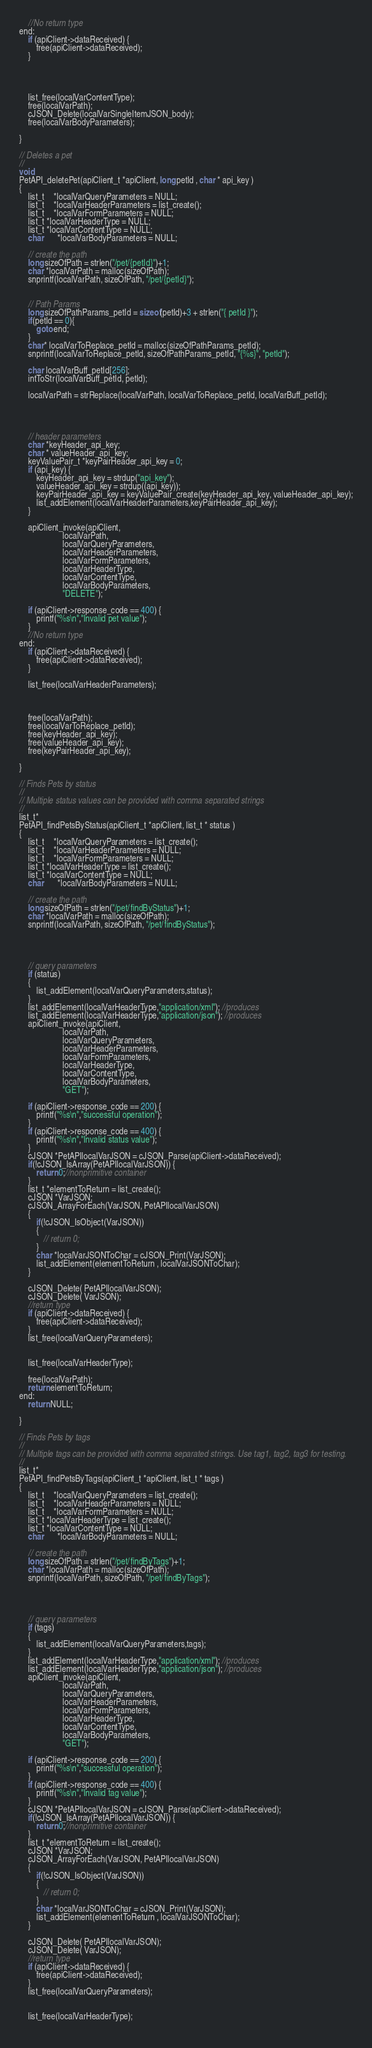Convert code to text. <code><loc_0><loc_0><loc_500><loc_500><_C_>    //No return type
end:
    if (apiClient->dataReceived) {
        free(apiClient->dataReceived);
    }
    
    
    
    
    list_free(localVarContentType);
    free(localVarPath);
    cJSON_Delete(localVarSingleItemJSON_body);
    free(localVarBodyParameters);

}

// Deletes a pet
//
void
PetAPI_deletePet(apiClient_t *apiClient, long petId , char * api_key )
{
    list_t    *localVarQueryParameters = NULL;
    list_t    *localVarHeaderParameters = list_create();
    list_t    *localVarFormParameters = NULL;
    list_t *localVarHeaderType = NULL;
    list_t *localVarContentType = NULL;
    char      *localVarBodyParameters = NULL;

    // create the path
    long sizeOfPath = strlen("/pet/{petId}")+1;
    char *localVarPath = malloc(sizeOfPath);
    snprintf(localVarPath, sizeOfPath, "/pet/{petId}");


    // Path Params
    long sizeOfPathParams_petId = sizeof(petId)+3 + strlen("{ petId }");
    if(petId == 0){
        goto end;
    }
    char* localVarToReplace_petId = malloc(sizeOfPathParams_petId);
    snprintf(localVarToReplace_petId, sizeOfPathParams_petId, "{%s}", "petId");

    char localVarBuff_petId[256];
    intToStr(localVarBuff_petId, petId);

    localVarPath = strReplace(localVarPath, localVarToReplace_petId, localVarBuff_petId);




    // header parameters
    char *keyHeader_api_key;
    char * valueHeader_api_key;
    keyValuePair_t *keyPairHeader_api_key = 0;
    if (api_key) {
        keyHeader_api_key = strdup("api_key");
        valueHeader_api_key = strdup((api_key));
        keyPairHeader_api_key = keyValuePair_create(keyHeader_api_key, valueHeader_api_key);
        list_addElement(localVarHeaderParameters,keyPairHeader_api_key);
    }

    apiClient_invoke(apiClient,
                    localVarPath,
                    localVarQueryParameters,
                    localVarHeaderParameters,
                    localVarFormParameters,
                    localVarHeaderType,
                    localVarContentType,
                    localVarBodyParameters,
                    "DELETE");

    if (apiClient->response_code == 400) {
        printf("%s\n","Invalid pet value");
    }
    //No return type
end:
    if (apiClient->dataReceived) {
        free(apiClient->dataReceived);
    }
    
    list_free(localVarHeaderParameters);
    
    
    
    free(localVarPath);
    free(localVarToReplace_petId);
    free(keyHeader_api_key);
    free(valueHeader_api_key);
    free(keyPairHeader_api_key);

}

// Finds Pets by status
//
// Multiple status values can be provided with comma separated strings
//
list_t*
PetAPI_findPetsByStatus(apiClient_t *apiClient, list_t * status )
{
    list_t    *localVarQueryParameters = list_create();
    list_t    *localVarHeaderParameters = NULL;
    list_t    *localVarFormParameters = NULL;
    list_t *localVarHeaderType = list_create();
    list_t *localVarContentType = NULL;
    char      *localVarBodyParameters = NULL;

    // create the path
    long sizeOfPath = strlen("/pet/findByStatus")+1;
    char *localVarPath = malloc(sizeOfPath);
    snprintf(localVarPath, sizeOfPath, "/pet/findByStatus");




    // query parameters
    if (status)
    {
        list_addElement(localVarQueryParameters,status);
    }
    list_addElement(localVarHeaderType,"application/xml"); //produces
    list_addElement(localVarHeaderType,"application/json"); //produces
    apiClient_invoke(apiClient,
                    localVarPath,
                    localVarQueryParameters,
                    localVarHeaderParameters,
                    localVarFormParameters,
                    localVarHeaderType,
                    localVarContentType,
                    localVarBodyParameters,
                    "GET");

    if (apiClient->response_code == 200) {
        printf("%s\n","successful operation");
    }
    if (apiClient->response_code == 400) {
        printf("%s\n","Invalid status value");
    }
    cJSON *PetAPIlocalVarJSON = cJSON_Parse(apiClient->dataReceived);
    if(!cJSON_IsArray(PetAPIlocalVarJSON)) {
        return 0;//nonprimitive container
    }
    list_t *elementToReturn = list_create();
    cJSON *VarJSON;
    cJSON_ArrayForEach(VarJSON, PetAPIlocalVarJSON)
    {
        if(!cJSON_IsObject(VarJSON))
        {
           // return 0;
        }
        char *localVarJSONToChar = cJSON_Print(VarJSON);
        list_addElement(elementToReturn , localVarJSONToChar);
    }

    cJSON_Delete( PetAPIlocalVarJSON);
    cJSON_Delete( VarJSON);
    //return type
    if (apiClient->dataReceived) {
        free(apiClient->dataReceived);
    }
    list_free(localVarQueryParameters);
    
    
    list_free(localVarHeaderType);
    
    free(localVarPath);
    return elementToReturn;
end:
    return NULL;

}

// Finds Pets by tags
//
// Multiple tags can be provided with comma separated strings. Use tag1, tag2, tag3 for testing.
//
list_t*
PetAPI_findPetsByTags(apiClient_t *apiClient, list_t * tags )
{
    list_t    *localVarQueryParameters = list_create();
    list_t    *localVarHeaderParameters = NULL;
    list_t    *localVarFormParameters = NULL;
    list_t *localVarHeaderType = list_create();
    list_t *localVarContentType = NULL;
    char      *localVarBodyParameters = NULL;

    // create the path
    long sizeOfPath = strlen("/pet/findByTags")+1;
    char *localVarPath = malloc(sizeOfPath);
    snprintf(localVarPath, sizeOfPath, "/pet/findByTags");




    // query parameters
    if (tags)
    {
        list_addElement(localVarQueryParameters,tags);
    }
    list_addElement(localVarHeaderType,"application/xml"); //produces
    list_addElement(localVarHeaderType,"application/json"); //produces
    apiClient_invoke(apiClient,
                    localVarPath,
                    localVarQueryParameters,
                    localVarHeaderParameters,
                    localVarFormParameters,
                    localVarHeaderType,
                    localVarContentType,
                    localVarBodyParameters,
                    "GET");

    if (apiClient->response_code == 200) {
        printf("%s\n","successful operation");
    }
    if (apiClient->response_code == 400) {
        printf("%s\n","Invalid tag value");
    }
    cJSON *PetAPIlocalVarJSON = cJSON_Parse(apiClient->dataReceived);
    if(!cJSON_IsArray(PetAPIlocalVarJSON)) {
        return 0;//nonprimitive container
    }
    list_t *elementToReturn = list_create();
    cJSON *VarJSON;
    cJSON_ArrayForEach(VarJSON, PetAPIlocalVarJSON)
    {
        if(!cJSON_IsObject(VarJSON))
        {
           // return 0;
        }
        char *localVarJSONToChar = cJSON_Print(VarJSON);
        list_addElement(elementToReturn , localVarJSONToChar);
    }

    cJSON_Delete( PetAPIlocalVarJSON);
    cJSON_Delete( VarJSON);
    //return type
    if (apiClient->dataReceived) {
        free(apiClient->dataReceived);
    }
    list_free(localVarQueryParameters);
    
    
    list_free(localVarHeaderType);
    </code> 